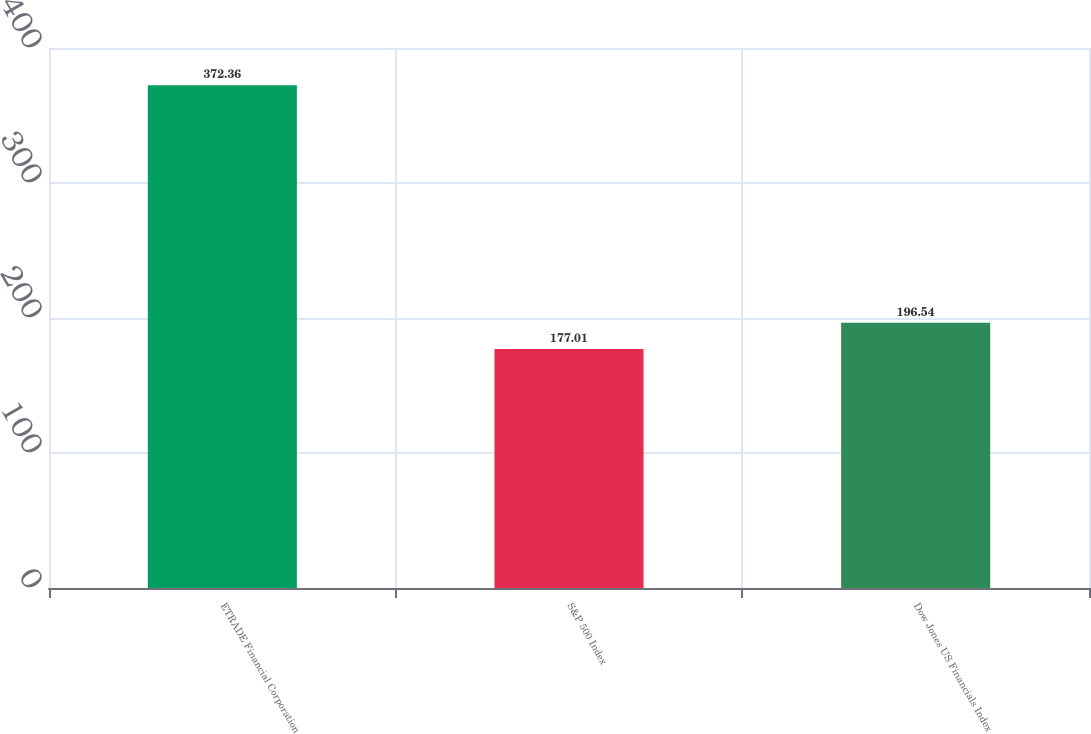Convert chart. <chart><loc_0><loc_0><loc_500><loc_500><bar_chart><fcel>ETRADE Financial Corporation<fcel>S&P 500 Index<fcel>Dow Jones US Financials Index<nl><fcel>372.36<fcel>177.01<fcel>196.54<nl></chart> 